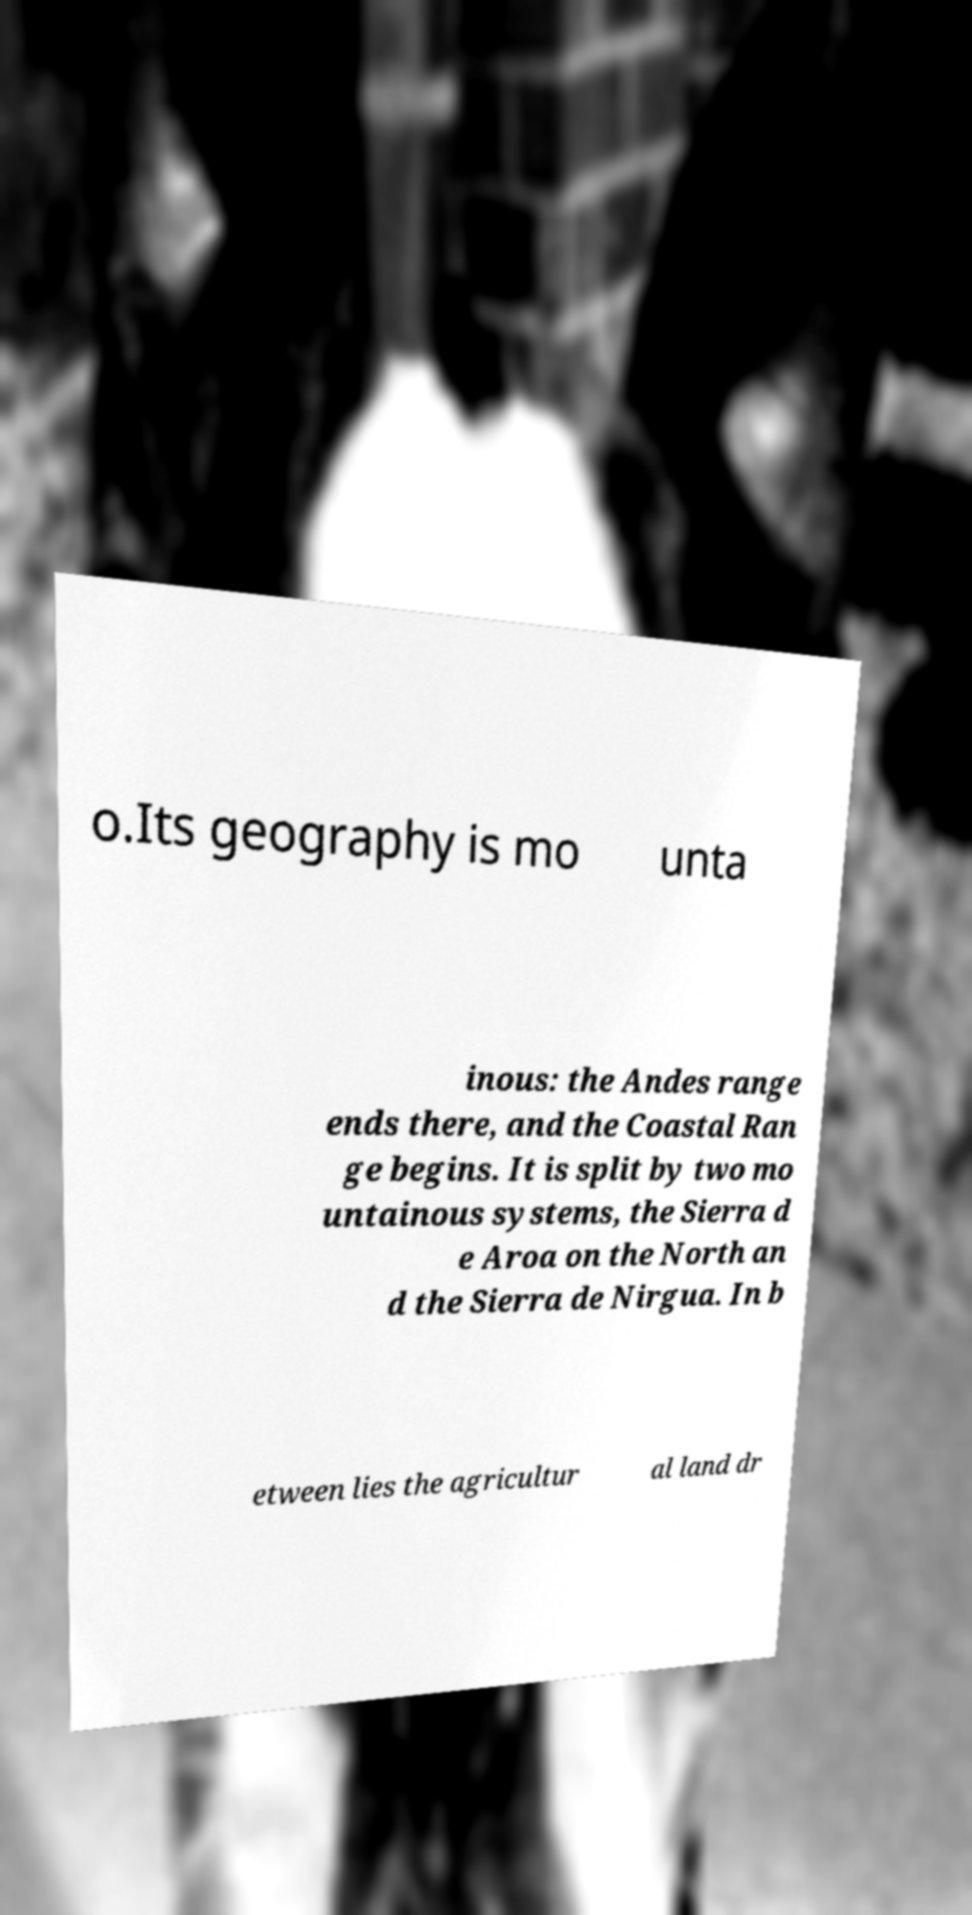Can you accurately transcribe the text from the provided image for me? o.Its geography is mo unta inous: the Andes range ends there, and the Coastal Ran ge begins. It is split by two mo untainous systems, the Sierra d e Aroa on the North an d the Sierra de Nirgua. In b etween lies the agricultur al land dr 